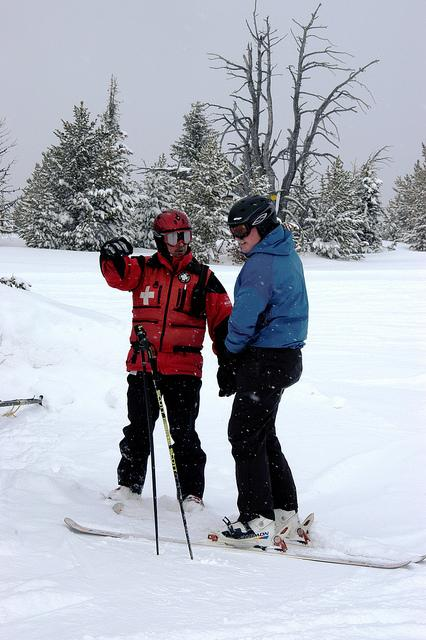What does the man in the red jacket's patch indicate? medic 